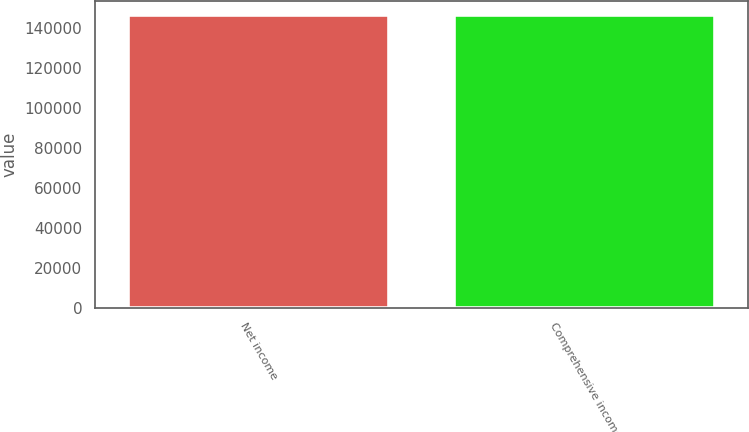Convert chart to OTSL. <chart><loc_0><loc_0><loc_500><loc_500><bar_chart><fcel>Net income<fcel>Comprehensive income<nl><fcel>146256<fcel>146256<nl></chart> 